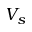<formula> <loc_0><loc_0><loc_500><loc_500>V _ { s }</formula> 